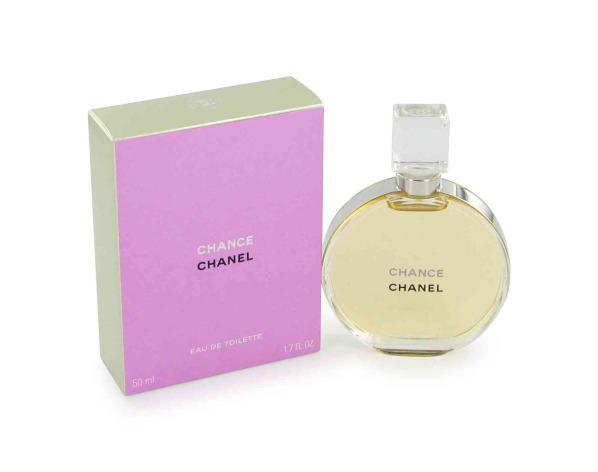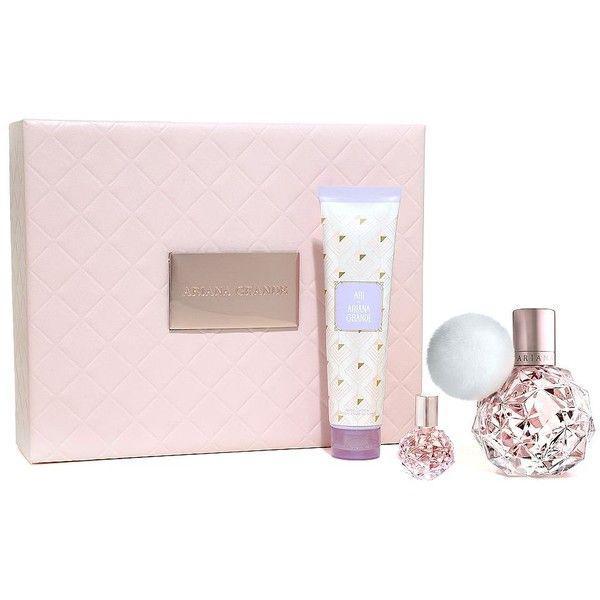The first image is the image on the left, the second image is the image on the right. Given the left and right images, does the statement "In at least one image there are at least two bottle of perfume and at least one box" hold true? Answer yes or no. Yes. 